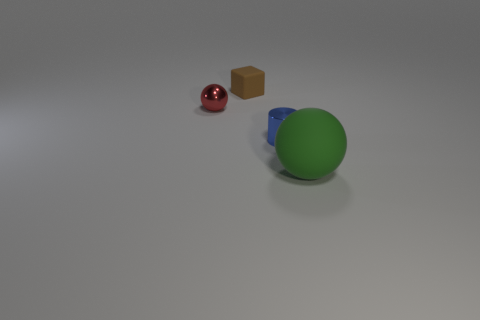There is a object that is behind the tiny thing to the left of the small brown thing; what is its color?
Make the answer very short. Brown. What number of other objects are the same material as the green thing?
Provide a short and direct response. 1. What number of other things are the same color as the small rubber block?
Offer a very short reply. 0. What material is the blue object right of the tiny metal thing that is on the left side of the brown object made of?
Provide a short and direct response. Metal. Are there any small things?
Provide a short and direct response. Yes. What is the size of the rubber object that is behind the metallic object on the right side of the red shiny ball?
Ensure brevity in your answer.  Small. Is the number of blue shiny cylinders in front of the large green thing greater than the number of large green matte spheres in front of the brown block?
Give a very brief answer. No. What number of blocks are metal things or green matte things?
Your answer should be very brief. 0. Are there any other things that have the same size as the brown block?
Offer a terse response. Yes. There is a rubber thing that is to the right of the small cube; is it the same shape as the small brown rubber object?
Keep it short and to the point. No. 